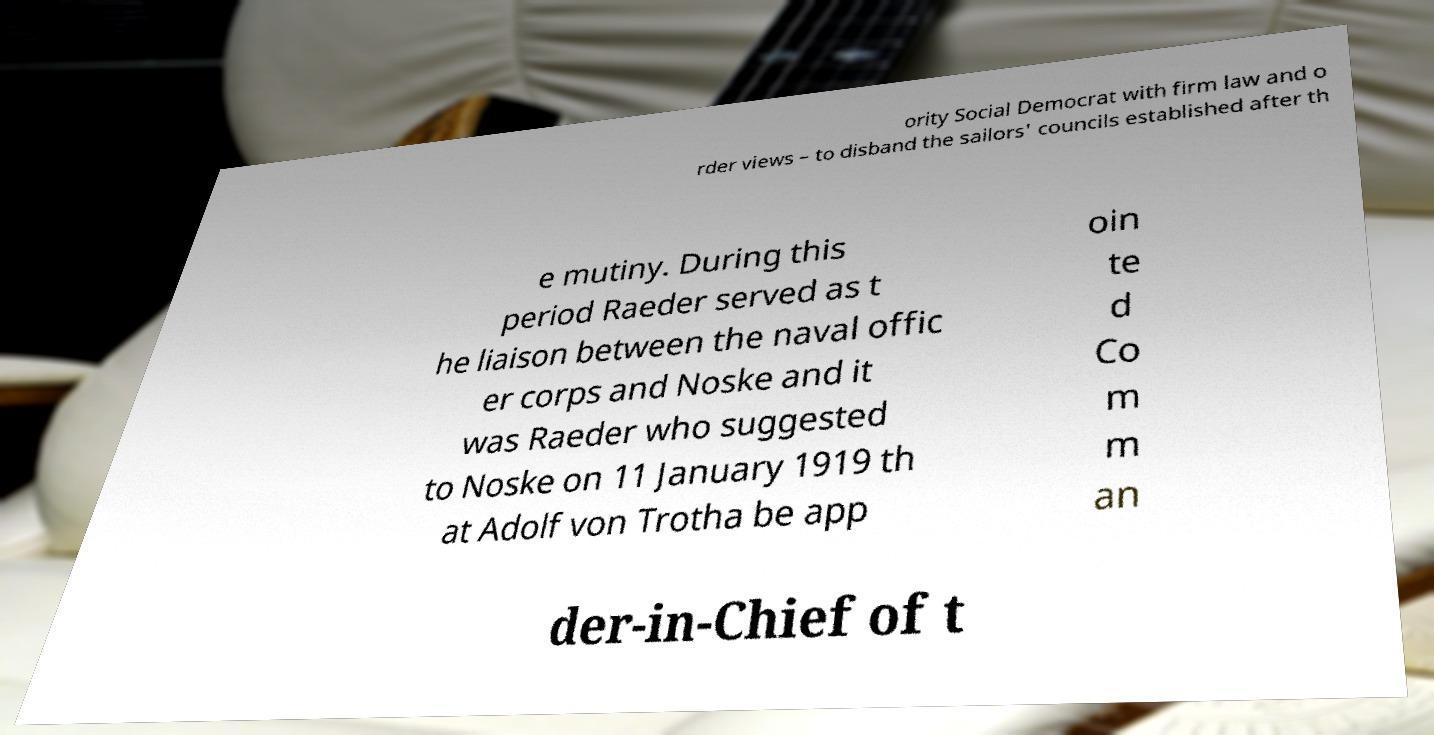Can you accurately transcribe the text from the provided image for me? ority Social Democrat with firm law and o rder views – to disband the sailors' councils established after th e mutiny. During this period Raeder served as t he liaison between the naval offic er corps and Noske and it was Raeder who suggested to Noske on 11 January 1919 th at Adolf von Trotha be app oin te d Co m m an der-in-Chief of t 